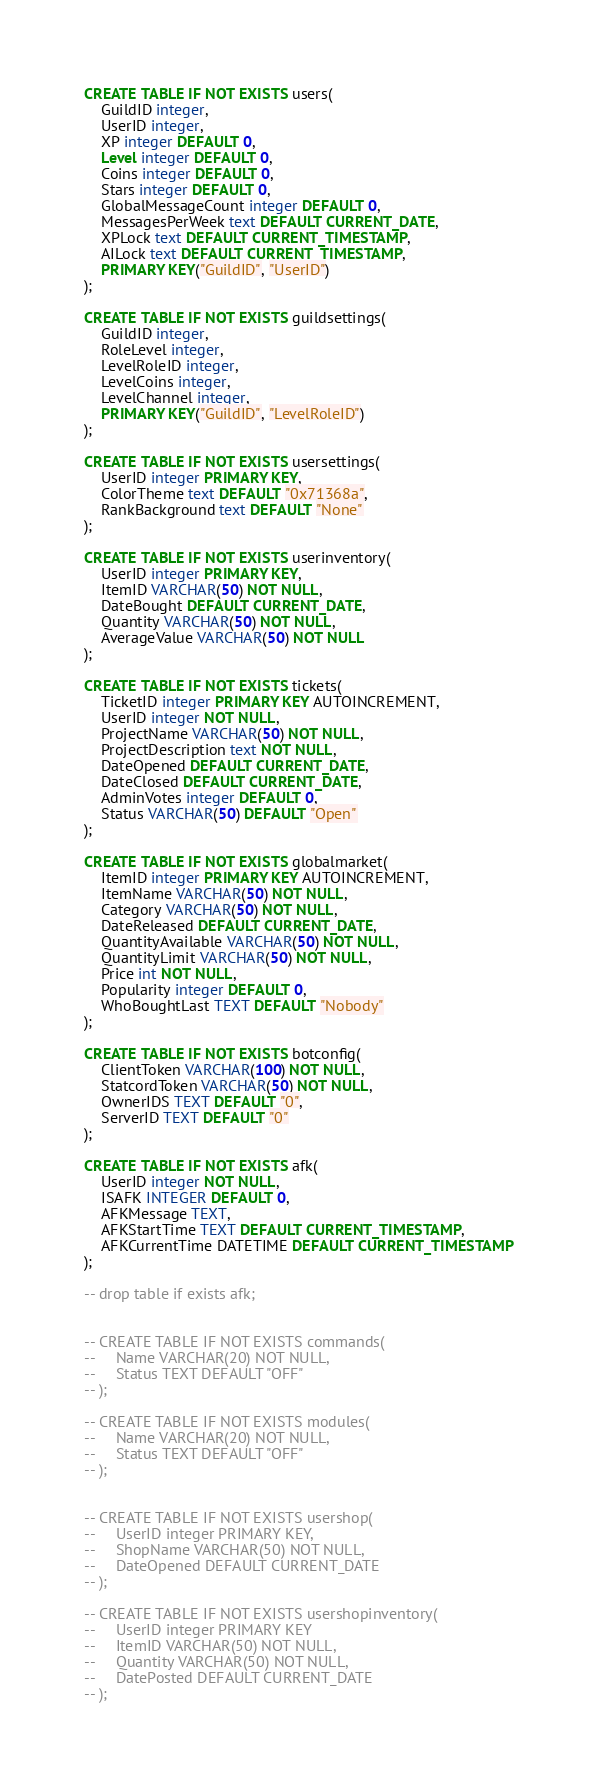<code> <loc_0><loc_0><loc_500><loc_500><_SQL_>CREATE TABLE IF NOT EXISTS users(
    GuildID integer,
    UserID integer,
    XP integer DEFAULT 0,
    Level integer DEFAULT 0,
    Coins integer DEFAULT 0,
    Stars integer DEFAULT 0,
    GlobalMessageCount integer DEFAULT 0,
    MessagesPerWeek text DEFAULT CURRENT_DATE,
    XPLock text DEFAULT CURRENT_TIMESTAMP,
    AILock text DEFAULT CURRENT_TIMESTAMP,
    PRIMARY KEY("GuildID", "UserID")
);

CREATE TABLE IF NOT EXISTS guildsettings(
    GuildID integer,
    RoleLevel integer,
    LevelRoleID integer,
    LevelCoins integer,
    LevelChannel integer,
    PRIMARY KEY("GuildID", "LevelRoleID")
);

CREATE TABLE IF NOT EXISTS usersettings(
    UserID integer PRIMARY KEY,
    ColorTheme text DEFAULT "0x71368a",
    RankBackground text DEFAULT "None"
);

CREATE TABLE IF NOT EXISTS userinventory(
    UserID integer PRIMARY KEY,
    ItemID VARCHAR(50) NOT NULL,
    DateBought DEFAULT CURRENT_DATE,
    Quantity VARCHAR(50) NOT NULL,
    AverageValue VARCHAR(50) NOT NULL
);

CREATE TABLE IF NOT EXISTS tickets(
    TicketID integer PRIMARY KEY AUTOINCREMENT,
    UserID integer NOT NULL,
    ProjectName VARCHAR(50) NOT NULL,
    ProjectDescription text NOT NULL,
    DateOpened DEFAULT CURRENT_DATE,
    DateClosed DEFAULT CURRENT_DATE,
    AdminVotes integer DEFAULT 0,
    Status VARCHAR(50) DEFAULT "Open"
);

CREATE TABLE IF NOT EXISTS globalmarket(
    ItemID integer PRIMARY KEY AUTOINCREMENT,
    ItemName VARCHAR(50) NOT NULL,
    Category VARCHAR(50) NOT NULL,
    DateReleased DEFAULT CURRENT_DATE,
    QuantityAvailable VARCHAR(50) NOT NULL,
    QuantityLimit VARCHAR(50) NOT NULL,
    Price int NOT NULL,
    Popularity integer DEFAULT 0,
    WhoBoughtLast TEXT DEFAULT "Nobody"
);

CREATE TABLE IF NOT EXISTS botconfig(
    ClientToken VARCHAR(100) NOT NULL,
    StatcordToken VARCHAR(50) NOT NULL,
    OwnerIDS TEXT DEFAULT "0",
    ServerID TEXT DEFAULT "0"
);

CREATE TABLE IF NOT EXISTS afk(
    UserID integer NOT NULL,
    ISAFK INTEGER DEFAULT 0,
    AFKMessage TEXT,
    AFKStartTime TEXT DEFAULT CURRENT_TIMESTAMP,
    AFKCurrentTime DATETIME DEFAULT CURRENT_TIMESTAMP
);

-- drop table if exists afk;


-- CREATE TABLE IF NOT EXISTS commands(
--     Name VARCHAR(20) NOT NULL,
--     Status TEXT DEFAULT "OFF"
-- );

-- CREATE TABLE IF NOT EXISTS modules(
--     Name VARCHAR(20) NOT NULL,
--     Status TEXT DEFAULT "OFF"
-- );


-- CREATE TABLE IF NOT EXISTS usershop(
--     UserID integer PRIMARY KEY,
--     ShopName VARCHAR(50) NOT NULL,
--     DateOpened DEFAULT CURRENT_DATE
-- );

-- CREATE TABLE IF NOT EXISTS usershopinventory(
--     UserID integer PRIMARY KEY
--     ItemID VARCHAR(50) NOT NULL,
--     Quantity VARCHAR(50) NOT NULL,
--     DatePosted DEFAULT CURRENT_DATE
-- );</code> 